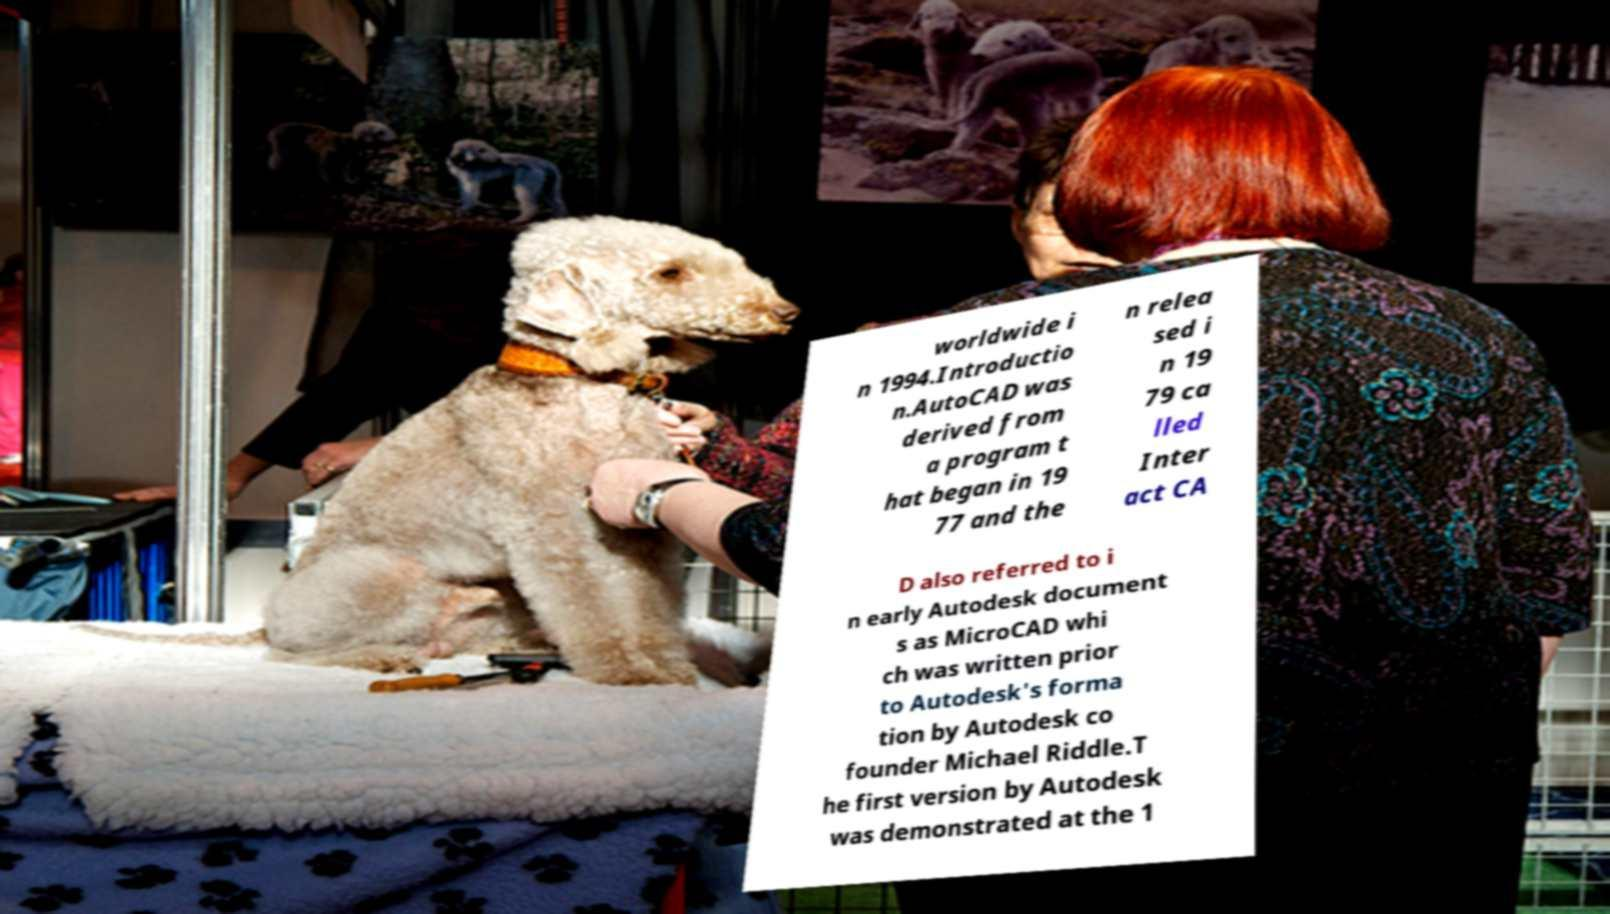What messages or text are displayed in this image? I need them in a readable, typed format. worldwide i n 1994.Introductio n.AutoCAD was derived from a program t hat began in 19 77 and the n relea sed i n 19 79 ca lled Inter act CA D also referred to i n early Autodesk document s as MicroCAD whi ch was written prior to Autodesk's forma tion by Autodesk co founder Michael Riddle.T he first version by Autodesk was demonstrated at the 1 